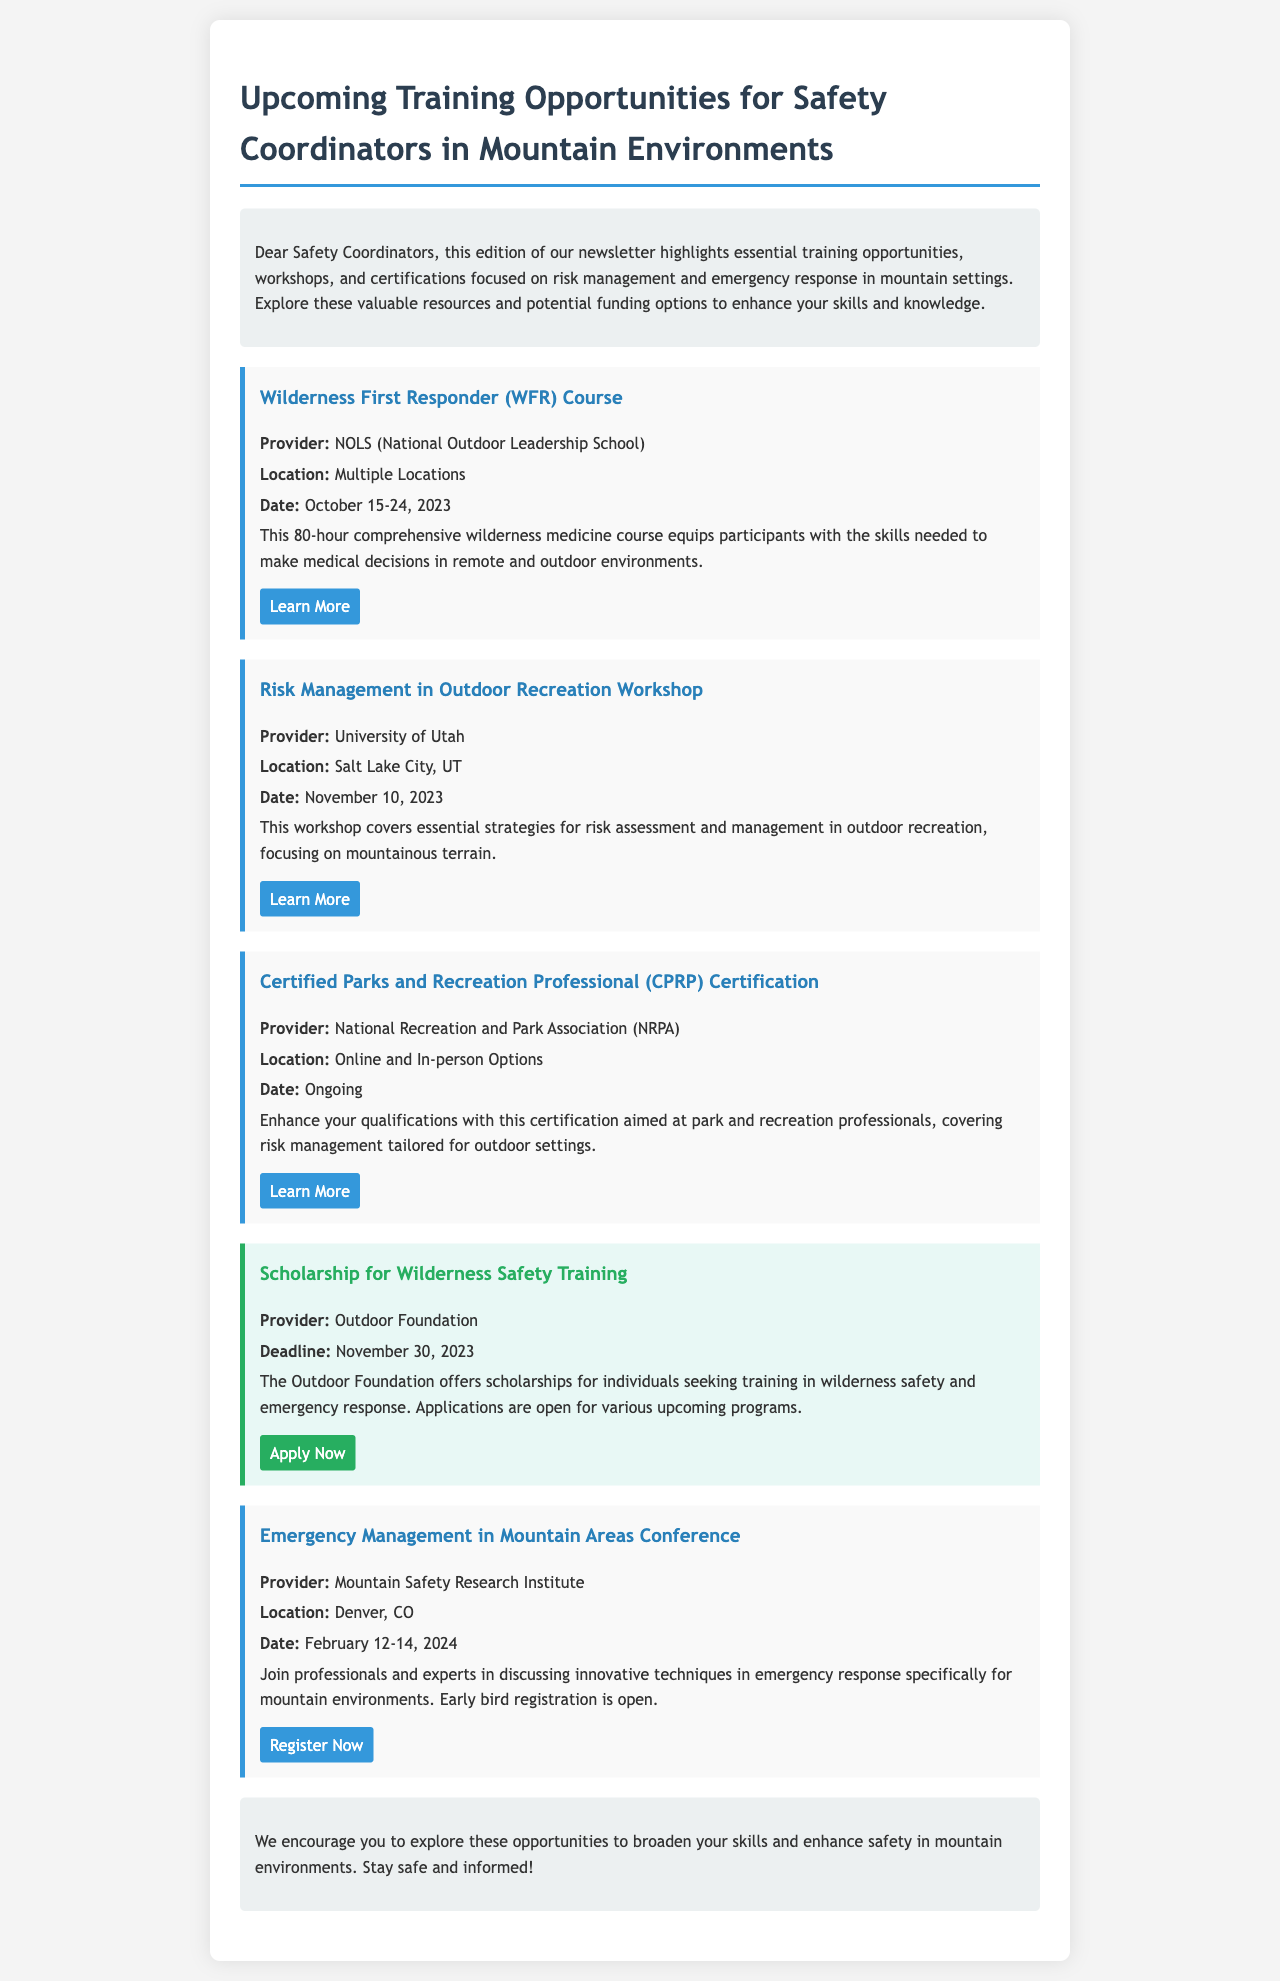What is the date of the Wilderness First Responder Course? The course date is specified in the document, which is October 15-24, 2023.
Answer: October 15-24, 2023 Who provides the Risk Management in Outdoor Recreation Workshop? The document lists the provider of the workshop, which is the University of Utah.
Answer: University of Utah What is the deadline for the scholarship for Wilderness Safety Training? The document mentions the scholarship deadline as November 30, 2023.
Answer: November 30, 2023 Which certification focuses on risk management tailored for outdoor settings? The document describes the Certified Parks and Recreation Professional certification that covers this area.
Answer: Certified Parks and Recreation Professional What is the location of the Emergency Management in Mountain Areas Conference? The document provides the conference location as Denver, CO.
Answer: Denver, CO How many days is the Wilderness First Responder course? The document indicates that the WFR course is 80 hours long.
Answer: 80 hours What organization offers scholarships for wilderness safety training? The document specifies that the Outdoor Foundation provides scholarships for this training.
Answer: Outdoor Foundation When is the Emergency Management in Mountain Areas Conference scheduled? The document states the conference dates, which are February 12-14, 2024.
Answer: February 12-14, 2024 